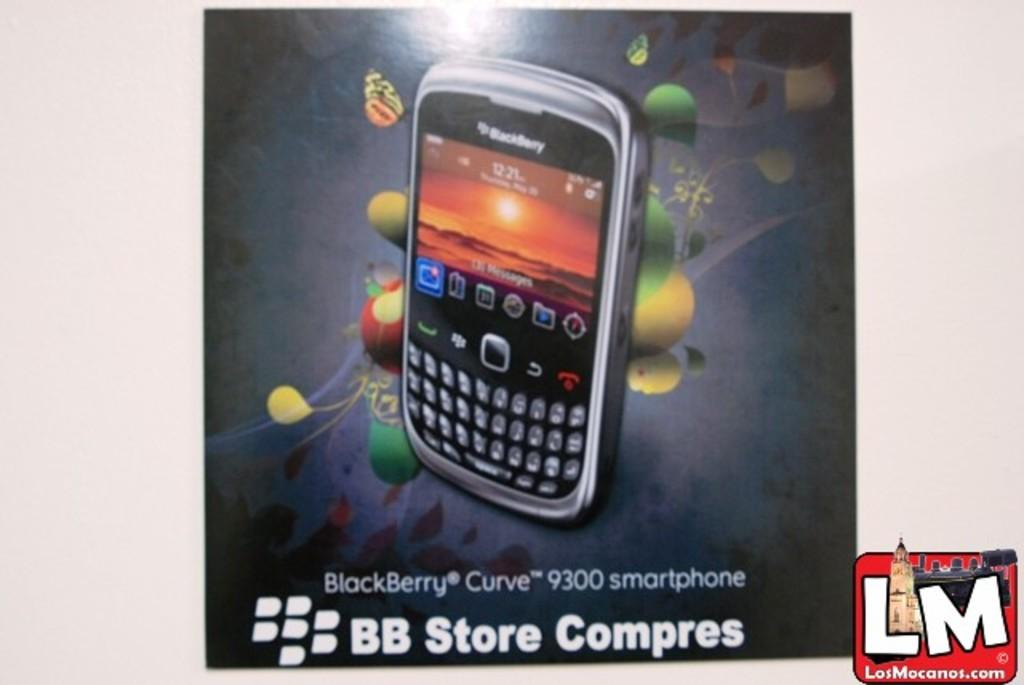<image>
Write a terse but informative summary of the picture. An advert for a blackberry branded device with the LM logo next to the advert. 